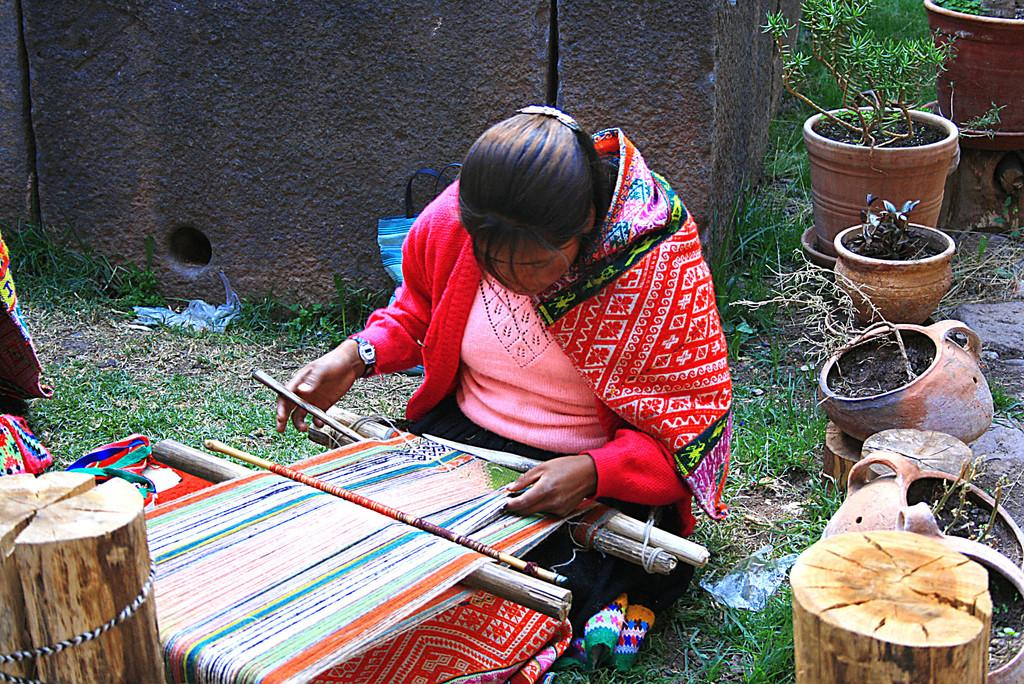Who is present in the image? There is a woman in the image. What is the woman doing in the image? The woman is sitting on the grassland and weaving clothes. What can be seen on the right side of the image? There are pots on the right side of the image. What is visible in the background of the image? There is a wall in the background of the image. What object is located in the bottom left of the image? There is a log in the bottom left of the image. What type of trail can be seen in the image? There is no trail visible in the image. How does the woman express her feelings towards the pots in the image? The image does not provide any information about the woman's feelings towards the pots. 